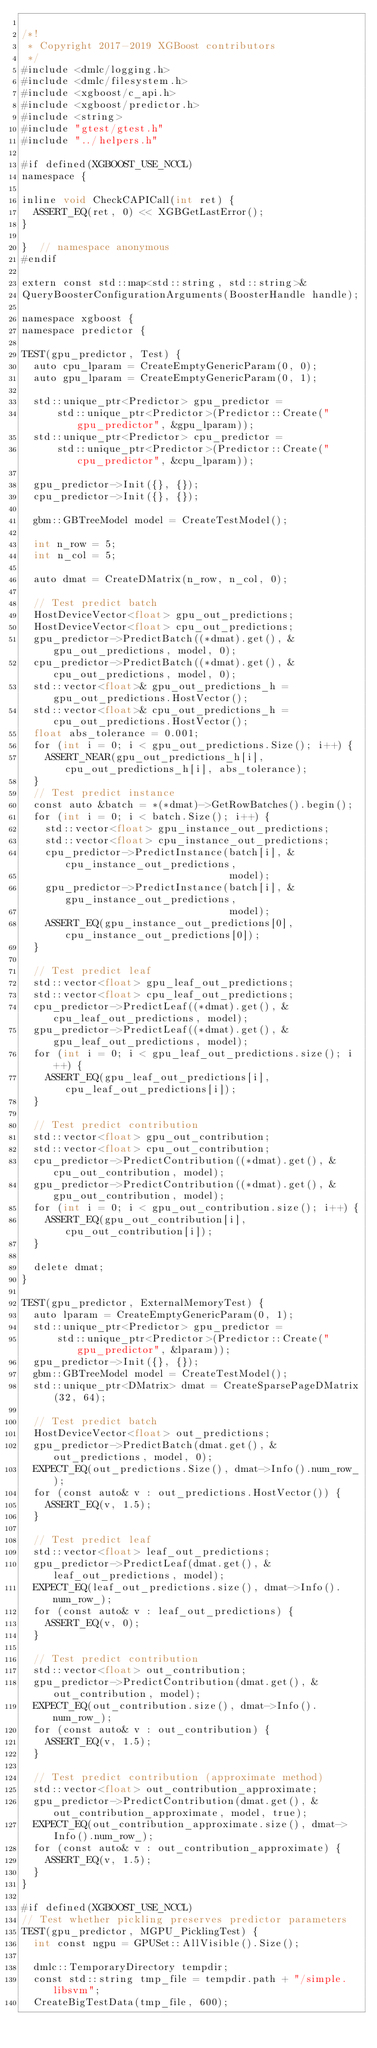Convert code to text. <code><loc_0><loc_0><loc_500><loc_500><_Cuda_>
/*!
 * Copyright 2017-2019 XGBoost contributors
 */
#include <dmlc/logging.h>
#include <dmlc/filesystem.h>
#include <xgboost/c_api.h>
#include <xgboost/predictor.h>
#include <string>
#include "gtest/gtest.h"
#include "../helpers.h"

#if defined(XGBOOST_USE_NCCL)
namespace {

inline void CheckCAPICall(int ret) {
  ASSERT_EQ(ret, 0) << XGBGetLastError();
}

}  // namespace anonymous
#endif

extern const std::map<std::string, std::string>&
QueryBoosterConfigurationArguments(BoosterHandle handle);

namespace xgboost {
namespace predictor {

TEST(gpu_predictor, Test) {
  auto cpu_lparam = CreateEmptyGenericParam(0, 0);
  auto gpu_lparam = CreateEmptyGenericParam(0, 1);

  std::unique_ptr<Predictor> gpu_predictor =
      std::unique_ptr<Predictor>(Predictor::Create("gpu_predictor", &gpu_lparam));
  std::unique_ptr<Predictor> cpu_predictor =
      std::unique_ptr<Predictor>(Predictor::Create("cpu_predictor", &cpu_lparam));

  gpu_predictor->Init({}, {});
  cpu_predictor->Init({}, {});

  gbm::GBTreeModel model = CreateTestModel();

  int n_row = 5;
  int n_col = 5;

  auto dmat = CreateDMatrix(n_row, n_col, 0);

  // Test predict batch
  HostDeviceVector<float> gpu_out_predictions;
  HostDeviceVector<float> cpu_out_predictions;
  gpu_predictor->PredictBatch((*dmat).get(), &gpu_out_predictions, model, 0);
  cpu_predictor->PredictBatch((*dmat).get(), &cpu_out_predictions, model, 0);
  std::vector<float>& gpu_out_predictions_h = gpu_out_predictions.HostVector();
  std::vector<float>& cpu_out_predictions_h = cpu_out_predictions.HostVector();
  float abs_tolerance = 0.001;
  for (int i = 0; i < gpu_out_predictions.Size(); i++) {
    ASSERT_NEAR(gpu_out_predictions_h[i], cpu_out_predictions_h[i], abs_tolerance);
  }
  // Test predict instance
  const auto &batch = *(*dmat)->GetRowBatches().begin();
  for (int i = 0; i < batch.Size(); i++) {
    std::vector<float> gpu_instance_out_predictions;
    std::vector<float> cpu_instance_out_predictions;
    cpu_predictor->PredictInstance(batch[i], &cpu_instance_out_predictions,
                                   model);
    gpu_predictor->PredictInstance(batch[i], &gpu_instance_out_predictions,
                                   model);
    ASSERT_EQ(gpu_instance_out_predictions[0], cpu_instance_out_predictions[0]);
  }

  // Test predict leaf
  std::vector<float> gpu_leaf_out_predictions;
  std::vector<float> cpu_leaf_out_predictions;
  cpu_predictor->PredictLeaf((*dmat).get(), &cpu_leaf_out_predictions, model);
  gpu_predictor->PredictLeaf((*dmat).get(), &gpu_leaf_out_predictions, model);
  for (int i = 0; i < gpu_leaf_out_predictions.size(); i++) {
    ASSERT_EQ(gpu_leaf_out_predictions[i], cpu_leaf_out_predictions[i]);
  }

  // Test predict contribution
  std::vector<float> gpu_out_contribution;
  std::vector<float> cpu_out_contribution;
  cpu_predictor->PredictContribution((*dmat).get(), &cpu_out_contribution, model);
  gpu_predictor->PredictContribution((*dmat).get(), &gpu_out_contribution, model);
  for (int i = 0; i < gpu_out_contribution.size(); i++) {
    ASSERT_EQ(gpu_out_contribution[i], cpu_out_contribution[i]);
  }

  delete dmat;
}

TEST(gpu_predictor, ExternalMemoryTest) {
  auto lparam = CreateEmptyGenericParam(0, 1);
  std::unique_ptr<Predictor> gpu_predictor =
      std::unique_ptr<Predictor>(Predictor::Create("gpu_predictor", &lparam));
  gpu_predictor->Init({}, {});
  gbm::GBTreeModel model = CreateTestModel();
  std::unique_ptr<DMatrix> dmat = CreateSparsePageDMatrix(32, 64);

  // Test predict batch
  HostDeviceVector<float> out_predictions;
  gpu_predictor->PredictBatch(dmat.get(), &out_predictions, model, 0);
  EXPECT_EQ(out_predictions.Size(), dmat->Info().num_row_);
  for (const auto& v : out_predictions.HostVector()) {
    ASSERT_EQ(v, 1.5);
  }

  // Test predict leaf
  std::vector<float> leaf_out_predictions;
  gpu_predictor->PredictLeaf(dmat.get(), &leaf_out_predictions, model);
  EXPECT_EQ(leaf_out_predictions.size(), dmat->Info().num_row_);
  for (const auto& v : leaf_out_predictions) {
    ASSERT_EQ(v, 0);
  }

  // Test predict contribution
  std::vector<float> out_contribution;
  gpu_predictor->PredictContribution(dmat.get(), &out_contribution, model);
  EXPECT_EQ(out_contribution.size(), dmat->Info().num_row_);
  for (const auto& v : out_contribution) {
    ASSERT_EQ(v, 1.5);
  }

  // Test predict contribution (approximate method)
  std::vector<float> out_contribution_approximate;
  gpu_predictor->PredictContribution(dmat.get(), &out_contribution_approximate, model, true);
  EXPECT_EQ(out_contribution_approximate.size(), dmat->Info().num_row_);
  for (const auto& v : out_contribution_approximate) {
    ASSERT_EQ(v, 1.5);
  }
}

#if defined(XGBOOST_USE_NCCL)
// Test whether pickling preserves predictor parameters
TEST(gpu_predictor, MGPU_PicklingTest) {
  int const ngpu = GPUSet::AllVisible().Size();

  dmlc::TemporaryDirectory tempdir;
  const std::string tmp_file = tempdir.path + "/simple.libsvm";
  CreateBigTestData(tmp_file, 600);
</code> 